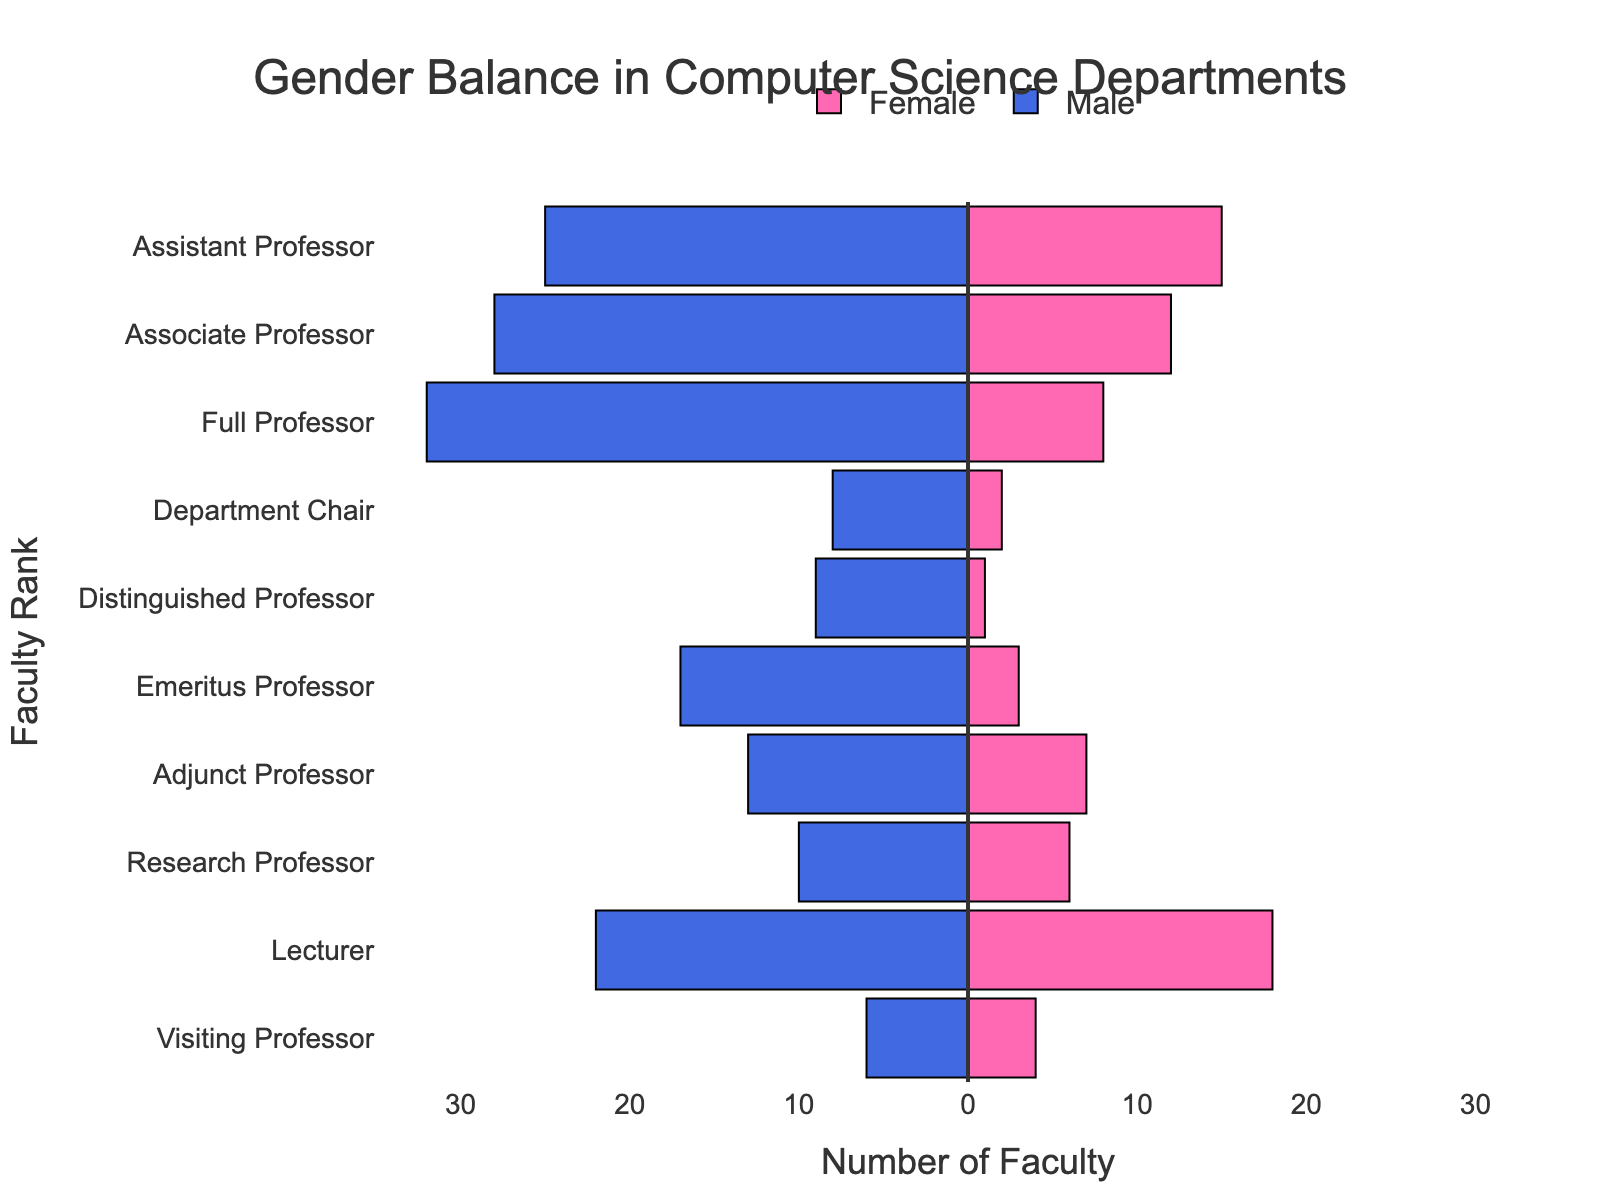What is the title of the figure? The title of the figure is displayed prominently at the top.
Answer: Gender Balance in Computer Science Departments How many Assistant Professors are there in total? Add the number of female and male Assistant Professors: 15 (Female) + 25 (Male) = 40.
Answer: 40 Which faculty rank has the most significant gender disparity? By comparing the difference between male and female faculty at each rank, Full Professor has the largest disparity: 32 (Male) - 8 (Female) = 24.
Answer: Full Professor What is the total number of female professors across all ranks? Sum the number of female faculty for each rank: 15 (Assistant) + 12 (Associate) + 8 (Full) + 2 (Chair) + 1 (Distinguished) + 3 (Emeritus) + 7 (Adjunct) + 6 (Research) + 18 (Lecturer) + 4 (Visiting) = 76.
Answer: 76 Which rank has the smallest number of male faculty? The number of male faculty for each rank is compared, and Distinguished Professor has the smallest number (9).
Answer: Distinguished Professor Which faculty ranks have more female than male faculty? Compare the counts for each rank to check where female faculty exceed male faculty: Lecturer (18 Female, 22 Male). None satisfies this.
Answer: None How does the number of female Lecturers compare to the number of female Full Professors? The number of female Lecturers is higher: 18 (Lecturers) vs. 8 (Full Professors).
Answer: Female Lecturers are more than Female Full Professors What is the ratio of male to female for the Department Chair rank? The number of males is 8 and females is 2, so the ratio is 8/2 = 4.
Answer: 4 How many more male Emeritus Professors are there than female? Subtract the number of female Emeritus Professors from the number of male Emeritus Professors: 17 (Male) - 3 (Female) = 14.
Answer: 14 Which rank has the most balanced gender representation, in terms of the smallest absolute difference? Compare the absolute differences between male and female faculty for each rank, Adjunct Professor has the smallest difference:
Answer: Adjunct Professor 